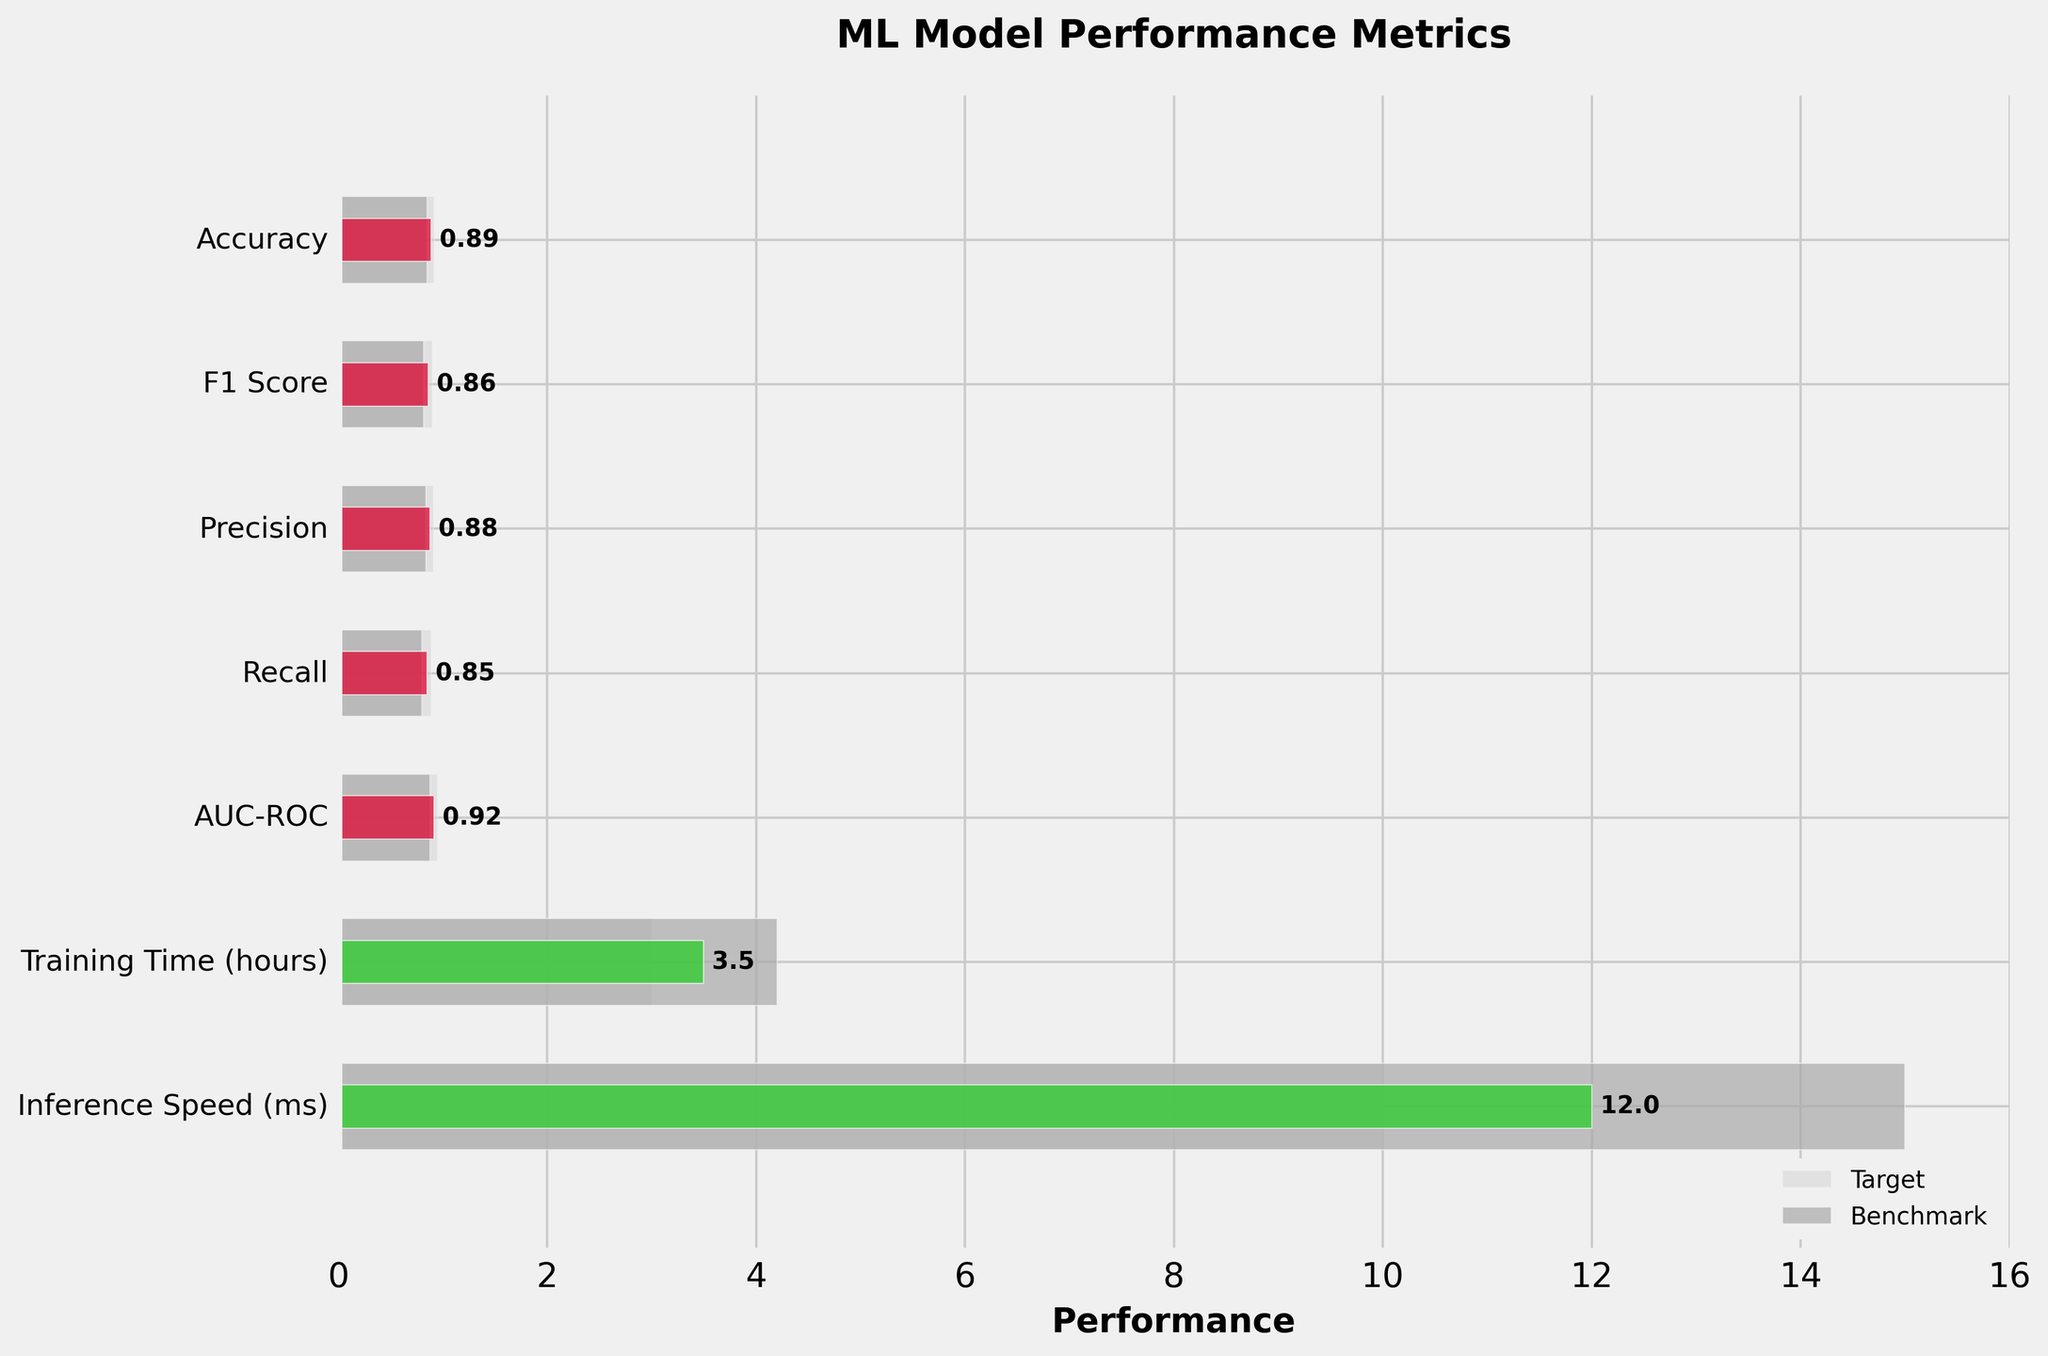What is the title of the figure? The title is usually located at the top center of the figure. It gives an overview of what the chart is about.
Answer: ML Model Performance Metrics How many performance metrics are shown in the figure? Count the number of distinct metrics listed on the y-axis.
Answer: 7 Which metric has the highest actual value? Look at the bars representing actual values and identify the one with the largest value.
Answer: AUC-ROC Does the model's Recall meet its target? Compare the actual Recall value to the target value.
Answer: No What is the difference between the actual and benchmark values for Training Time? Subtract the benchmark value from the actual value for Training Time. 3.5 - 4.2 = -0.7
Answer: -0.7 Which performance metric shows the most significant difference between the actual and target values? Calculate the absolute difference between the actual and target values for all metrics and find the largest one.
Answer: Accuracy Are there any metrics where the benchmark value is higher than the actual value? If so, list them. Compare each metric's benchmark value against its actual value and identify where the benchmark is higher.
Answer: Training Time Looking at the Inference Speed, is the performance of the model better than the benchmark? Compare the actual Inference Speed to the benchmark speed; lower times are better.
Answer: Yes What color is used for the actual values that meet or exceed their targets? The color for the corresponding bars indicates values meeting or exceeding targets, as mentioned in the code. It's specified for visibility purposes.
Answer: Limegreen Which metric is the closest to its target without exceeding it? Identify the metric with the actual value closest to, but not above, its target. Compare all differences where actual ≤ target.
Answer: Precision 